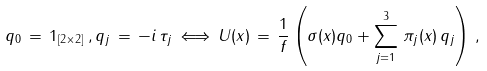<formula> <loc_0><loc_0><loc_500><loc_500>q _ { 0 } \, = \, 1 _ { [ 2 \times 2 ] } \, , q _ { j } \, = \, - i \, \tau _ { j } \, \Longleftrightarrow \, U ( x ) \, = \, { \frac { 1 } { f } } \left ( \sigma ( x ) q _ { 0 } + \sum _ { j = 1 } ^ { 3 } \, \pi _ { j } ( x ) \, q _ { j } \right ) \, ,</formula> 